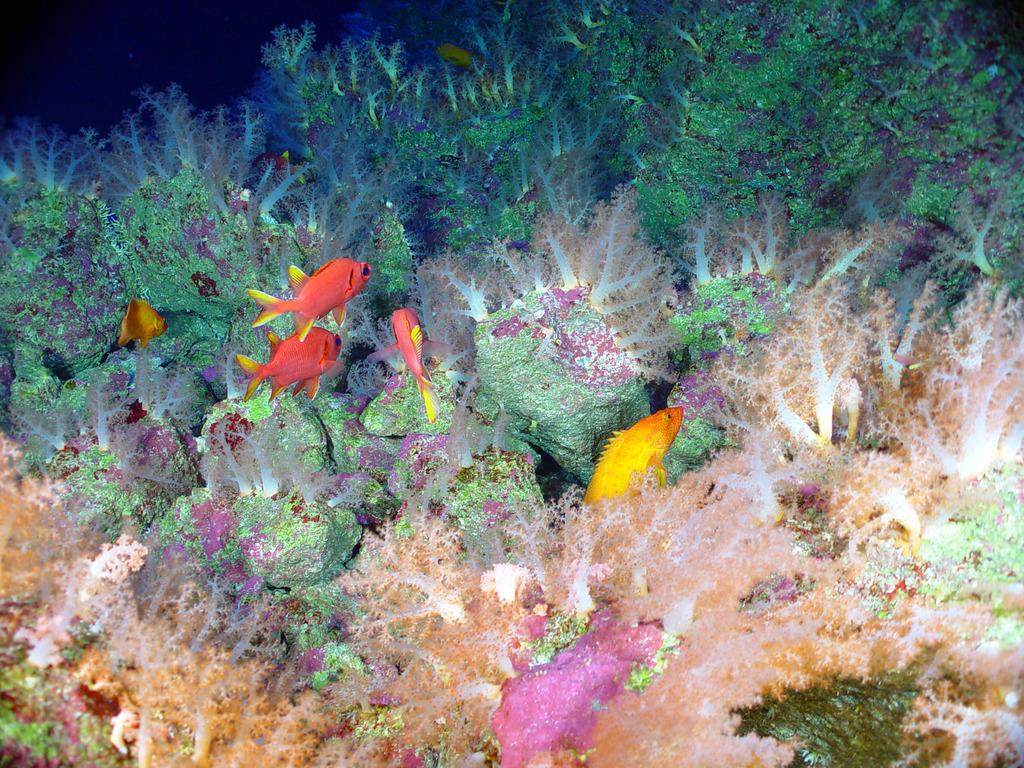What is happening in the water in the image? There are fishes moving in the water. What can be seen in the water besides the fishes? The image appears to depict coral plants under the water. What type of coil is being used by the fishes to navigate the water? There is no coil present in the image; the fishes are moving freely in the water. What kind of apparel is worn by the coral plants in the image? There is no apparel present in the image, as coral plants are not living beings that wear clothing. 